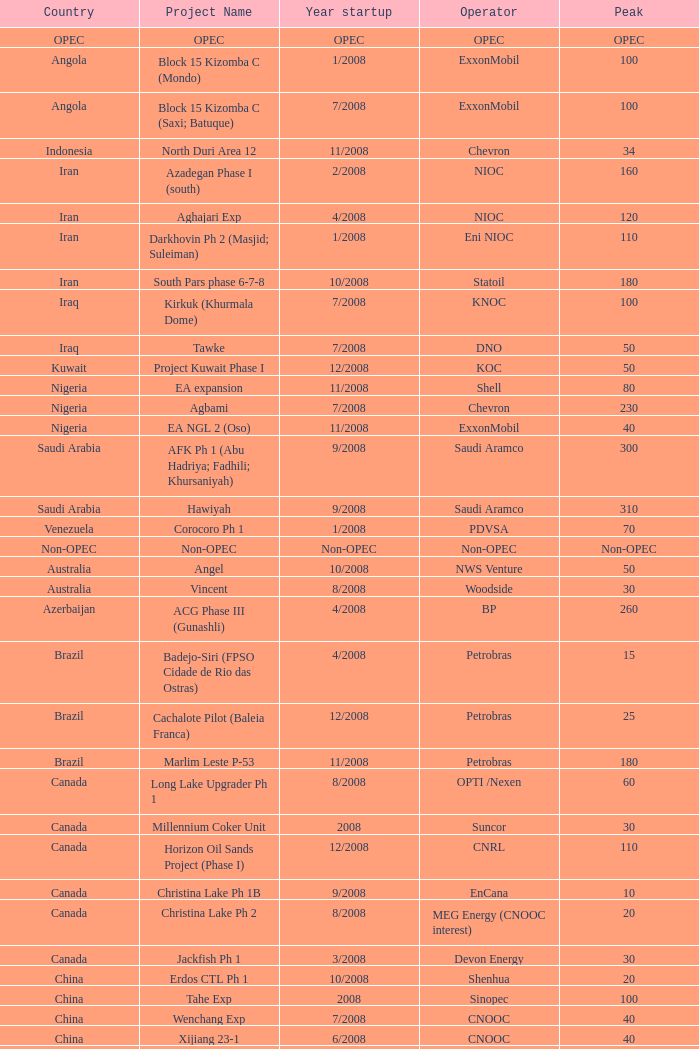What is the Project Name with a Country that is kazakhstan and a Peak that is 150? Dunga. Help me parse the entirety of this table. {'header': ['Country', 'Project Name', 'Year startup', 'Operator', 'Peak'], 'rows': [['OPEC', 'OPEC', 'OPEC', 'OPEC', 'OPEC'], ['Angola', 'Block 15 Kizomba C (Mondo)', '1/2008', 'ExxonMobil', '100'], ['Angola', 'Block 15 Kizomba C (Saxi; Batuque)', '7/2008', 'ExxonMobil', '100'], ['Indonesia', 'North Duri Area 12', '11/2008', 'Chevron', '34'], ['Iran', 'Azadegan Phase I (south)', '2/2008', 'NIOC', '160'], ['Iran', 'Aghajari Exp', '4/2008', 'NIOC', '120'], ['Iran', 'Darkhovin Ph 2 (Masjid; Suleiman)', '1/2008', 'Eni NIOC', '110'], ['Iran', 'South Pars phase 6-7-8', '10/2008', 'Statoil', '180'], ['Iraq', 'Kirkuk (Khurmala Dome)', '7/2008', 'KNOC', '100'], ['Iraq', 'Tawke', '7/2008', 'DNO', '50'], ['Kuwait', 'Project Kuwait Phase I', '12/2008', 'KOC', '50'], ['Nigeria', 'EA expansion', '11/2008', 'Shell', '80'], ['Nigeria', 'Agbami', '7/2008', 'Chevron', '230'], ['Nigeria', 'EA NGL 2 (Oso)', '11/2008', 'ExxonMobil', '40'], ['Saudi Arabia', 'AFK Ph 1 (Abu Hadriya; Fadhili; Khursaniyah)', '9/2008', 'Saudi Aramco', '300'], ['Saudi Arabia', 'Hawiyah', '9/2008', 'Saudi Aramco', '310'], ['Venezuela', 'Corocoro Ph 1', '1/2008', 'PDVSA', '70'], ['Non-OPEC', 'Non-OPEC', 'Non-OPEC', 'Non-OPEC', 'Non-OPEC'], ['Australia', 'Angel', '10/2008', 'NWS Venture', '50'], ['Australia', 'Vincent', '8/2008', 'Woodside', '30'], ['Azerbaijan', 'ACG Phase III (Gunashli)', '4/2008', 'BP', '260'], ['Brazil', 'Badejo-Siri (FPSO Cidade de Rio das Ostras)', '4/2008', 'Petrobras', '15'], ['Brazil', 'Cachalote Pilot (Baleia Franca)', '12/2008', 'Petrobras', '25'], ['Brazil', 'Marlim Leste P-53', '11/2008', 'Petrobras', '180'], ['Canada', 'Long Lake Upgrader Ph 1', '8/2008', 'OPTI /Nexen', '60'], ['Canada', 'Millennium Coker Unit', '2008', 'Suncor', '30'], ['Canada', 'Horizon Oil Sands Project (Phase I)', '12/2008', 'CNRL', '110'], ['Canada', 'Christina Lake Ph 1B', '9/2008', 'EnCana', '10'], ['Canada', 'Christina Lake Ph 2', '8/2008', 'MEG Energy (CNOOC interest)', '20'], ['Canada', 'Jackfish Ph 1', '3/2008', 'Devon Energy', '30'], ['China', 'Erdos CTL Ph 1', '10/2008', 'Shenhua', '20'], ['China', 'Tahe Exp', '2008', 'Sinopec', '100'], ['China', 'Wenchang Exp', '7/2008', 'CNOOC', '40'], ['China', 'Xijiang 23-1', '6/2008', 'CNOOC', '40'], ['Congo', 'Moho Bilondo', '4/2008', 'Total', '90'], ['Egypt', 'Saqqara', '3/2008', 'BP', '40'], ['India', 'MA field (KG-D6)', '9/2008', 'Reliance', '40'], ['Kazakhstan', 'Dunga', '3/2008', 'Maersk', '150'], ['Kazakhstan', 'Komsomolskoe', '5/2008', 'Petrom', '10'], ['Mexico', '( Chicontepec ) Exp 1', '2008', 'PEMEX', '200'], ['Mexico', 'Antonio J Bermudez Exp', '5/2008', 'PEMEX', '20'], ['Mexico', 'Bellota Chinchorro Exp', '5/2008', 'PEMEX', '20'], ['Mexico', 'Ixtal Manik', '2008', 'PEMEX', '55'], ['Mexico', 'Jujo Tecominoacan Exp', '2008', 'PEMEX', '15'], ['Norway', 'Alvheim; Volund; Vilje', '6/2008', 'Marathon', '100'], ['Norway', 'Volve', '2/2008', 'StatoilHydro', '35'], ['Oman', 'Mukhaizna EOR Ph 1', '2008', 'Occidental', '40'], ['Philippines', 'Galoc', '10/2008', 'GPC', '15'], ['Russia', 'Talakan Ph 1', '10/2008', 'Surgutneftegaz', '60'], ['Russia', 'Verkhnechonsk Ph 1 (early oil)', '10/2008', 'TNK-BP Rosneft', '20'], ['Russia', 'Yuzhno-Khylchuyuskoye "YK" Ph 1', '8/2008', 'Lukoil ConocoPhillips', '75'], ['Thailand', 'Bualuang', '8/2008', 'Salamander', '10'], ['UK', 'Britannia Satellites (Callanish; Brodgar)', '7/2008', 'Conoco Phillips', '25'], ['USA', 'Blind Faith', '11/2008', 'Chevron', '45'], ['USA', 'Neptune', '7/2008', 'BHP Billiton', '25'], ['USA', 'Oooguruk', '6/2008', 'Pioneer', '15'], ['USA', 'Qannik', '7/2008', 'ConocoPhillips', '4'], ['USA', 'Thunder Horse', '6/2008', 'BP', '210'], ['USA', 'Ursa Princess Exp', '1/2008', 'Shell', '30'], ['Vietnam', 'Ca Ngu Vang (Golden Tuna)', '7/2008', 'HVJOC', '15'], ['Vietnam', 'Su Tu Vang', '10/2008', 'Cuu Long Joint', '40'], ['Vietnam', 'Song Doc', '12/2008', 'Talisman', '10']]} 